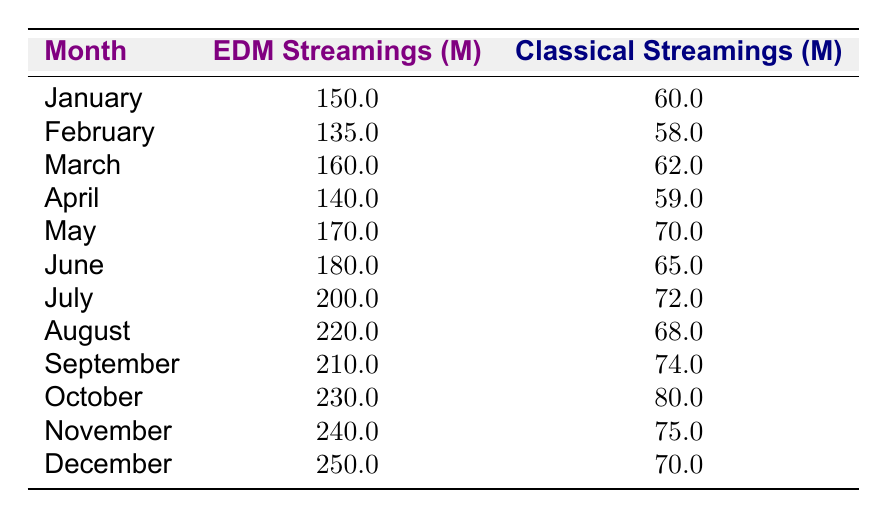What is the total number of EDM streamings in December? From the table, in December, the number of EDM streamings is clearly indicated as 250,000,000.
Answer: 250,000,000 What month had the highest Classical streamings? Scanning through the table, the month with the highest Classical streamings is October with 80,000,000.
Answer: October What is the difference between EDM streamings in May and Classical streamings in May? In May, EDM streamings are 170,000,000 and Classical streamings are 70,000,000. The difference is 170,000,000 - 70,000,000 = 100,000,000.
Answer: 100,000,000 What was the average number of Classical streamings from January to March? The Classical streamings for January, February, and March are 60,000,000, 58,000,000, and 62,000,000 respectively. Summing these gives 60 + 58 + 62 = 180. Dividing by 3 (the number of months) provides an average of 180,000,000 / 3 = 60,000,000.
Answer: 60,000,000 Are there any months where EDM streamings were less than Classical streamings? By inspecting the data in the table, all months show that EDM streamings are greater than Classical streamings, confirming that this statement is false.
Answer: No Which month saw the greatest increase in EDM streamings compared to the previous month? To find this, compare each month's EDM streamings with the previous month: January to February shows a decrease, February to March an increase of 25,000,000 (March - February = 160 - 135), and so on. The greatest increase is from July to August, where streamings increased from 200,000,000 to 220,000,000, totaling an increase of 20,000,000.
Answer: August What is the total number of EDM streamings from May to October? We summarize the EDM streamings for May (170,000,000), June (180,000,000), July (200,000,000), August (220,000,000), September (210,000,000), October (230,000,000). The total is 170 + 180 + 200 + 220 + 210 + 230 = 1,210,000,000.
Answer: 1,210,000,000 Is the average number of Classical streamings for the second half of the year greater than the first half? The total for the first half is 60 + 58 + 62 + 59 + 70 + 65 = 384. For the second half: 72 + 68 + 74 + 80 + 75 + 70 = 439. Dividing both by 6 gives the first half an average of 64,000,000 and the second half an average of 73,166,667, confirming that the latter is indeed greater.
Answer: Yes 